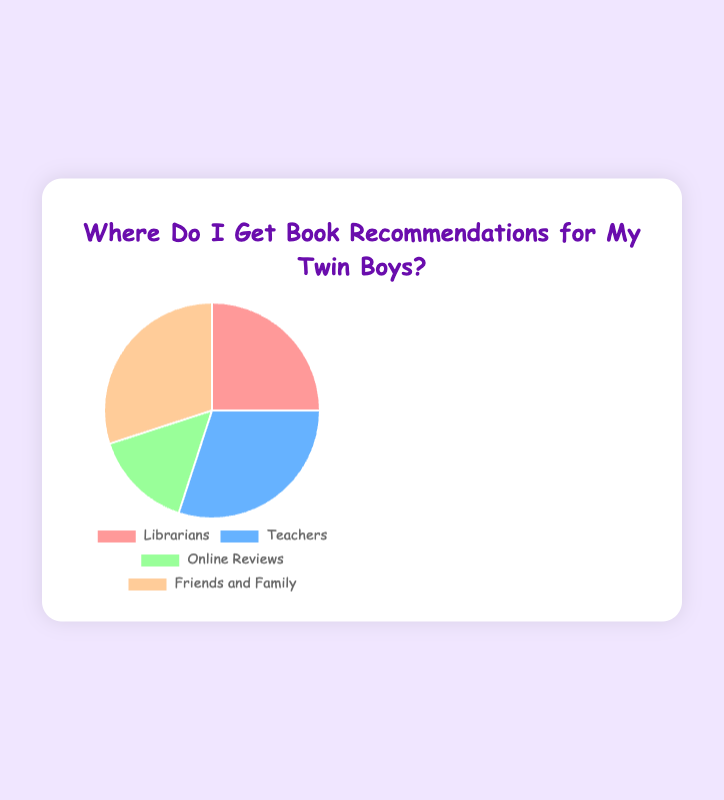What sources have the highest percentage for book recommendations? From the pie chart, Teachers and Friends and Family each contribute 30% to the sources of book recommendations, making them the highest.
Answer: Teachers and Friends and Family What is the total percentage accounted for by Librarians and Online Reviews? Adding the percentages of Librarians (25%) and Online Reviews (15%), we get 25 + 15 = 40%.
Answer: 40% Which source contributes the least to book recommendations? From the pie chart, the source with the smallest slice represents Online Reviews with 15%.
Answer: Online Reviews How much more does Teachers and Friends and Family combined contribute than Librarians? Teachers and Friends and Family combined contribute 30% + 30% = 60%. Subtracting the contribution of Librarians (25%) from this gives 60% - 25% = 35%.
Answer: 35% What is the average percentage contributed by all sources? The total percentage is 25% (Librarians) + 30% (Teachers) + 15% (Online Reviews) + 30% (Friends and Family) = 100%. Dividing by the number of sources (4), we get 100% / 4 = 25%.
Answer: 25% What is the difference in percentage points between the highest and lowest contributing sources? The highest contributing sources are Teachers and Friends and Family at 30% each, and the lowest is Online Reviews at 15%. The difference is 30% - 15% = 15 percentage points.
Answer: 15 percentage points How many sources contribute more than 20%? From the pie chart, Librarians (25%), Teachers (30%), and Friends and Family (30%) each contribute more than 20%. This totals 3 sources.
Answer: 3 sources Which segment is represented by the color blue? Typically, the color blue is labeled next to "Teachers" in the pie chart data provided.
Answer: Teachers Are there any sources that contribute an equal percentage to book recommendations? If so, which ones? Yes, Teachers and Friends and Family each contribute 30% to book recommendations, which are equal.
Answer: Teachers and Friends and Family If the percentage of Online Reviews increased by 10%, what would the new percentage be? The current percentage for Online Reviews is 15%. Adding 10% to this gives 15% + 10% = 25%.
Answer: 25% 